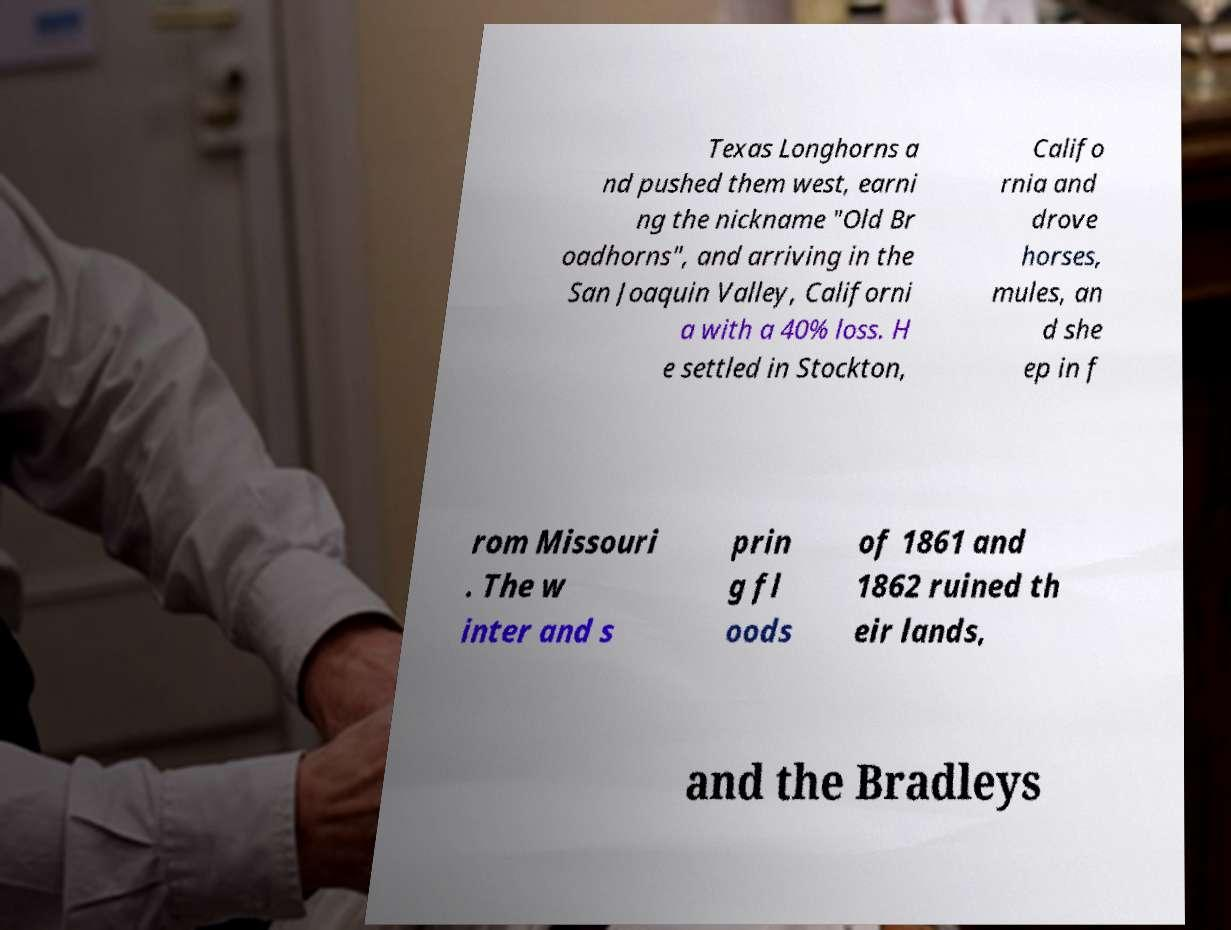Please identify and transcribe the text found in this image. Texas Longhorns a nd pushed them west, earni ng the nickname "Old Br oadhorns", and arriving in the San Joaquin Valley, Californi a with a 40% loss. H e settled in Stockton, Califo rnia and drove horses, mules, an d she ep in f rom Missouri . The w inter and s prin g fl oods of 1861 and 1862 ruined th eir lands, and the Bradleys 